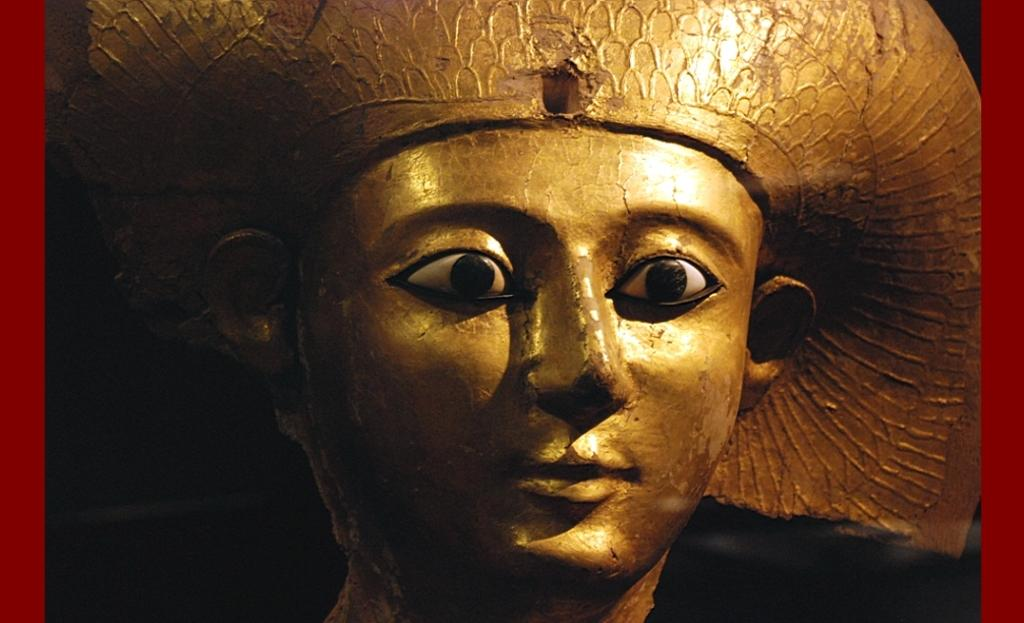What is the main subject in the image? There is a statue in the image. What can be seen in the background of the image? The background of the image is red. How many rooms are visible in the image? There is no room visible in the image; it features a statue with a red background. What type of scale is used to measure the size of the statue in the image? There is no scale present in the image, and the size of the statue cannot be determined from the provided facts. 